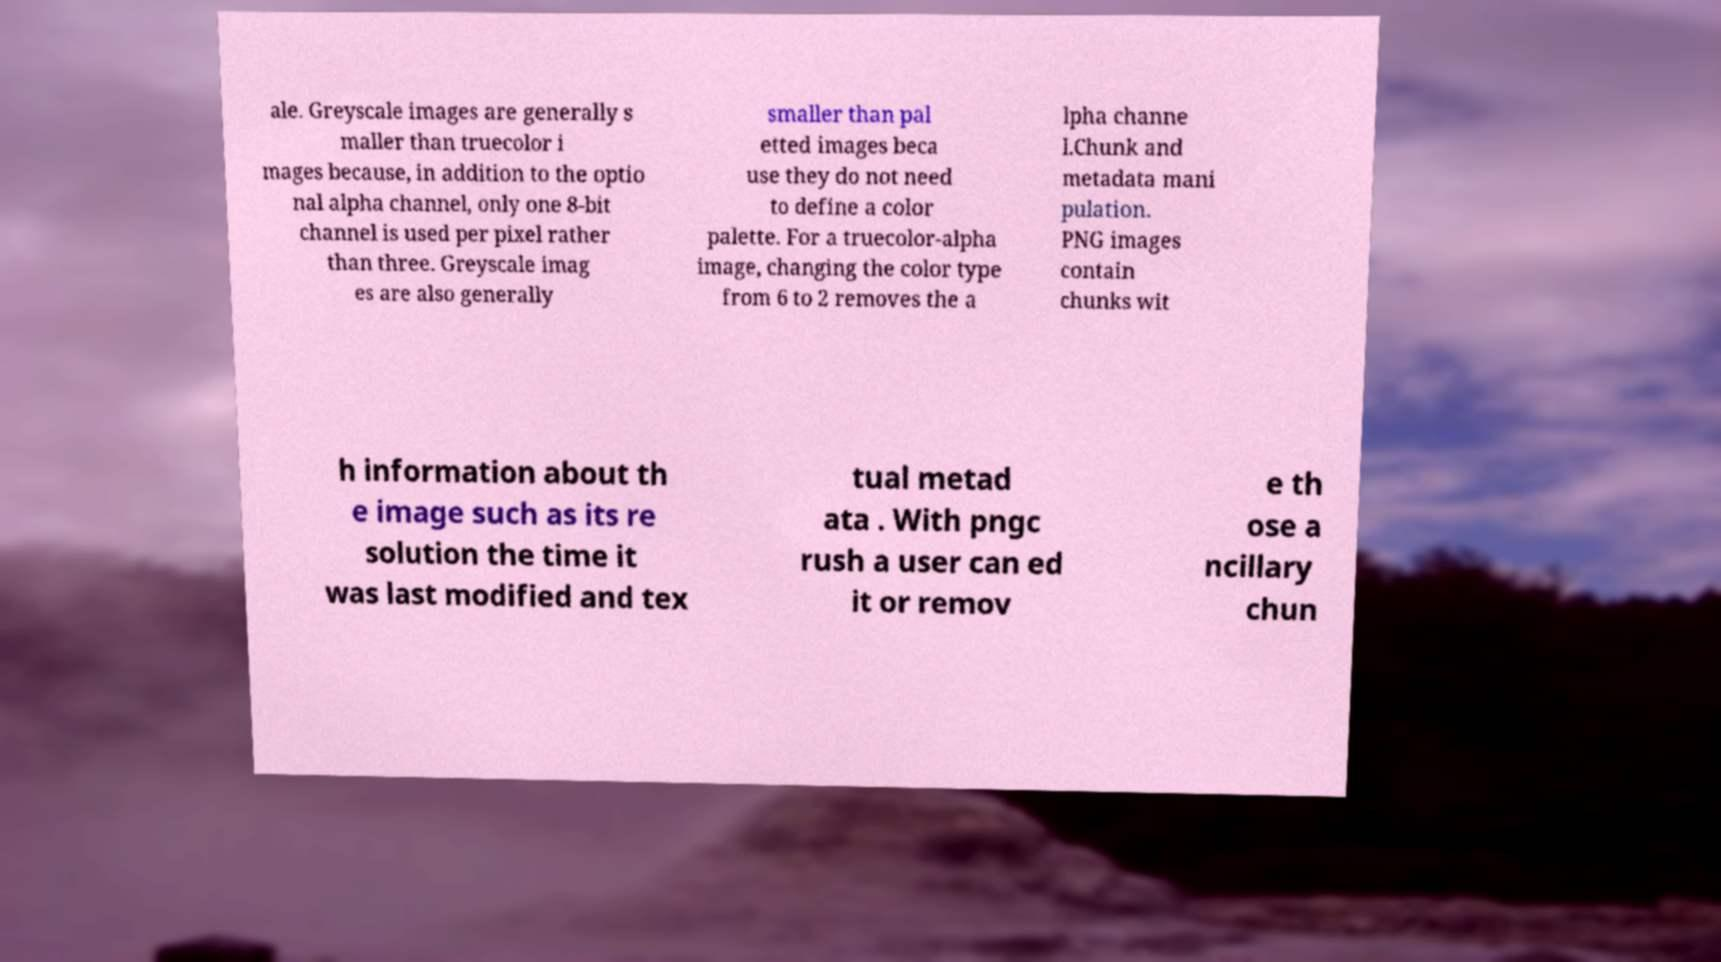Please read and relay the text visible in this image. What does it say? ale. Greyscale images are generally s maller than truecolor i mages because, in addition to the optio nal alpha channel, only one 8-bit channel is used per pixel rather than three. Greyscale imag es are also generally smaller than pal etted images beca use they do not need to define a color palette. For a truecolor-alpha image, changing the color type from 6 to 2 removes the a lpha channe l.Chunk and metadata mani pulation. PNG images contain chunks wit h information about th e image such as its re solution the time it was last modified and tex tual metad ata . With pngc rush a user can ed it or remov e th ose a ncillary chun 